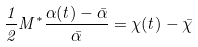<formula> <loc_0><loc_0><loc_500><loc_500>\frac { 1 } { 2 } M ^ { * } \frac { \alpha ( t ) - \bar { \alpha } } { \bar { \alpha } } = \chi ( t ) - \bar { \chi }</formula> 